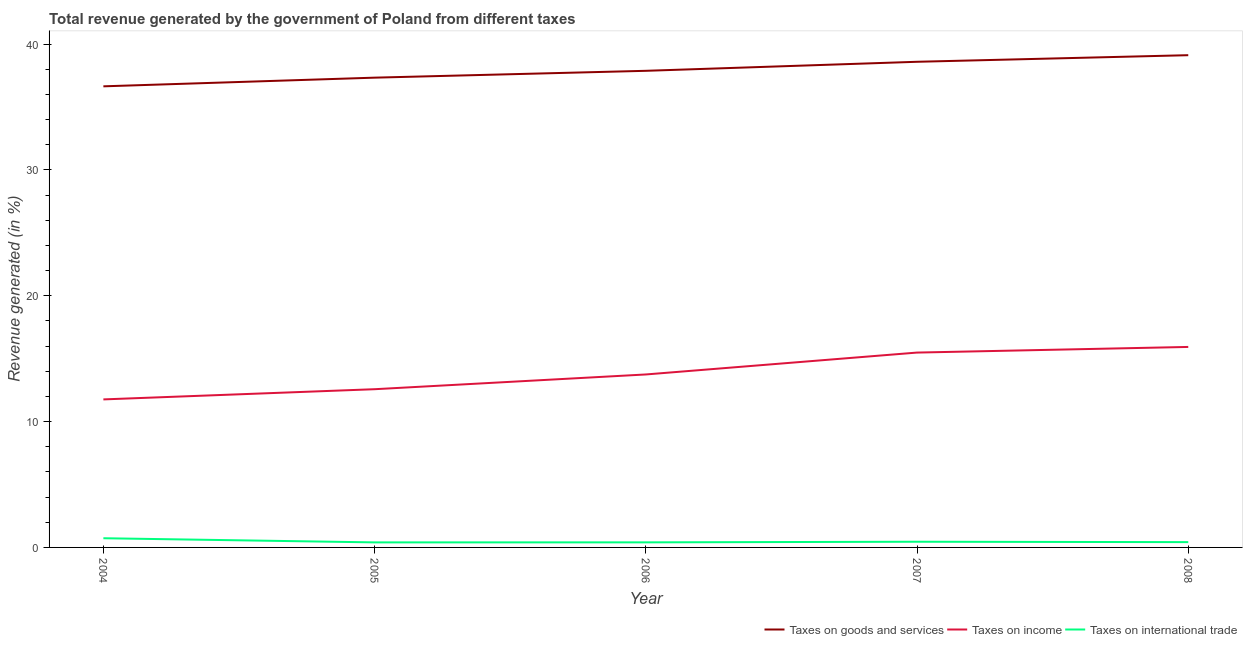How many different coloured lines are there?
Your answer should be compact. 3. Does the line corresponding to percentage of revenue generated by taxes on goods and services intersect with the line corresponding to percentage of revenue generated by taxes on income?
Offer a very short reply. No. What is the percentage of revenue generated by taxes on income in 2008?
Offer a very short reply. 15.93. Across all years, what is the maximum percentage of revenue generated by tax on international trade?
Keep it short and to the point. 0.73. Across all years, what is the minimum percentage of revenue generated by taxes on income?
Ensure brevity in your answer.  11.76. What is the total percentage of revenue generated by taxes on income in the graph?
Give a very brief answer. 69.51. What is the difference between the percentage of revenue generated by taxes on goods and services in 2007 and that in 2008?
Make the answer very short. -0.52. What is the difference between the percentage of revenue generated by taxes on goods and services in 2008 and the percentage of revenue generated by tax on international trade in 2006?
Your answer should be very brief. 38.72. What is the average percentage of revenue generated by tax on international trade per year?
Your response must be concise. 0.48. In the year 2007, what is the difference between the percentage of revenue generated by taxes on income and percentage of revenue generated by taxes on goods and services?
Your answer should be compact. -23.11. What is the ratio of the percentage of revenue generated by taxes on income in 2004 to that in 2006?
Give a very brief answer. 0.86. Is the percentage of revenue generated by taxes on goods and services in 2006 less than that in 2007?
Provide a short and direct response. Yes. What is the difference between the highest and the second highest percentage of revenue generated by tax on international trade?
Give a very brief answer. 0.28. What is the difference between the highest and the lowest percentage of revenue generated by taxes on goods and services?
Your response must be concise. 2.48. Is the sum of the percentage of revenue generated by taxes on income in 2004 and 2008 greater than the maximum percentage of revenue generated by taxes on goods and services across all years?
Your answer should be compact. No. Is the percentage of revenue generated by tax on international trade strictly greater than the percentage of revenue generated by taxes on income over the years?
Provide a succinct answer. No. How many lines are there?
Your response must be concise. 3. What is the difference between two consecutive major ticks on the Y-axis?
Your answer should be very brief. 10. Are the values on the major ticks of Y-axis written in scientific E-notation?
Make the answer very short. No. How many legend labels are there?
Your answer should be very brief. 3. What is the title of the graph?
Make the answer very short. Total revenue generated by the government of Poland from different taxes. Does "Poland" appear as one of the legend labels in the graph?
Provide a succinct answer. No. What is the label or title of the X-axis?
Your answer should be very brief. Year. What is the label or title of the Y-axis?
Your answer should be very brief. Revenue generated (in %). What is the Revenue generated (in %) of Taxes on goods and services in 2004?
Provide a succinct answer. 36.65. What is the Revenue generated (in %) of Taxes on income in 2004?
Your answer should be very brief. 11.76. What is the Revenue generated (in %) of Taxes on international trade in 2004?
Your answer should be compact. 0.73. What is the Revenue generated (in %) of Taxes on goods and services in 2005?
Offer a very short reply. 37.34. What is the Revenue generated (in %) in Taxes on income in 2005?
Provide a short and direct response. 12.57. What is the Revenue generated (in %) of Taxes on international trade in 2005?
Provide a short and direct response. 0.4. What is the Revenue generated (in %) of Taxes on goods and services in 2006?
Your response must be concise. 37.88. What is the Revenue generated (in %) of Taxes on income in 2006?
Offer a terse response. 13.75. What is the Revenue generated (in %) in Taxes on international trade in 2006?
Provide a succinct answer. 0.4. What is the Revenue generated (in %) of Taxes on goods and services in 2007?
Keep it short and to the point. 38.6. What is the Revenue generated (in %) in Taxes on income in 2007?
Your response must be concise. 15.49. What is the Revenue generated (in %) in Taxes on international trade in 2007?
Your answer should be very brief. 0.45. What is the Revenue generated (in %) of Taxes on goods and services in 2008?
Your answer should be very brief. 39.12. What is the Revenue generated (in %) of Taxes on income in 2008?
Your answer should be compact. 15.93. What is the Revenue generated (in %) of Taxes on international trade in 2008?
Make the answer very short. 0.42. Across all years, what is the maximum Revenue generated (in %) in Taxes on goods and services?
Provide a succinct answer. 39.12. Across all years, what is the maximum Revenue generated (in %) of Taxes on income?
Provide a succinct answer. 15.93. Across all years, what is the maximum Revenue generated (in %) in Taxes on international trade?
Give a very brief answer. 0.73. Across all years, what is the minimum Revenue generated (in %) of Taxes on goods and services?
Your answer should be compact. 36.65. Across all years, what is the minimum Revenue generated (in %) of Taxes on income?
Make the answer very short. 11.76. Across all years, what is the minimum Revenue generated (in %) in Taxes on international trade?
Ensure brevity in your answer.  0.4. What is the total Revenue generated (in %) in Taxes on goods and services in the graph?
Your response must be concise. 189.58. What is the total Revenue generated (in %) in Taxes on income in the graph?
Ensure brevity in your answer.  69.51. What is the total Revenue generated (in %) of Taxes on international trade in the graph?
Provide a succinct answer. 2.41. What is the difference between the Revenue generated (in %) in Taxes on goods and services in 2004 and that in 2005?
Your response must be concise. -0.69. What is the difference between the Revenue generated (in %) of Taxes on income in 2004 and that in 2005?
Provide a short and direct response. -0.81. What is the difference between the Revenue generated (in %) of Taxes on international trade in 2004 and that in 2005?
Ensure brevity in your answer.  0.33. What is the difference between the Revenue generated (in %) in Taxes on goods and services in 2004 and that in 2006?
Offer a very short reply. -1.23. What is the difference between the Revenue generated (in %) of Taxes on income in 2004 and that in 2006?
Your answer should be compact. -1.98. What is the difference between the Revenue generated (in %) in Taxes on international trade in 2004 and that in 2006?
Provide a succinct answer. 0.33. What is the difference between the Revenue generated (in %) in Taxes on goods and services in 2004 and that in 2007?
Offer a terse response. -1.95. What is the difference between the Revenue generated (in %) of Taxes on income in 2004 and that in 2007?
Provide a succinct answer. -3.72. What is the difference between the Revenue generated (in %) in Taxes on international trade in 2004 and that in 2007?
Provide a succinct answer. 0.28. What is the difference between the Revenue generated (in %) in Taxes on goods and services in 2004 and that in 2008?
Offer a terse response. -2.48. What is the difference between the Revenue generated (in %) of Taxes on income in 2004 and that in 2008?
Ensure brevity in your answer.  -4.17. What is the difference between the Revenue generated (in %) of Taxes on international trade in 2004 and that in 2008?
Your answer should be compact. 0.31. What is the difference between the Revenue generated (in %) in Taxes on goods and services in 2005 and that in 2006?
Give a very brief answer. -0.54. What is the difference between the Revenue generated (in %) of Taxes on income in 2005 and that in 2006?
Make the answer very short. -1.17. What is the difference between the Revenue generated (in %) in Taxes on international trade in 2005 and that in 2006?
Your answer should be very brief. -0. What is the difference between the Revenue generated (in %) of Taxes on goods and services in 2005 and that in 2007?
Your answer should be very brief. -1.26. What is the difference between the Revenue generated (in %) of Taxes on income in 2005 and that in 2007?
Provide a short and direct response. -2.91. What is the difference between the Revenue generated (in %) in Taxes on international trade in 2005 and that in 2007?
Provide a succinct answer. -0.05. What is the difference between the Revenue generated (in %) of Taxes on goods and services in 2005 and that in 2008?
Your response must be concise. -1.79. What is the difference between the Revenue generated (in %) in Taxes on income in 2005 and that in 2008?
Offer a terse response. -3.36. What is the difference between the Revenue generated (in %) in Taxes on international trade in 2005 and that in 2008?
Your answer should be very brief. -0.02. What is the difference between the Revenue generated (in %) in Taxes on goods and services in 2006 and that in 2007?
Ensure brevity in your answer.  -0.72. What is the difference between the Revenue generated (in %) of Taxes on income in 2006 and that in 2007?
Your response must be concise. -1.74. What is the difference between the Revenue generated (in %) in Taxes on international trade in 2006 and that in 2007?
Offer a terse response. -0.05. What is the difference between the Revenue generated (in %) of Taxes on goods and services in 2006 and that in 2008?
Your response must be concise. -1.24. What is the difference between the Revenue generated (in %) in Taxes on income in 2006 and that in 2008?
Provide a succinct answer. -2.19. What is the difference between the Revenue generated (in %) of Taxes on international trade in 2006 and that in 2008?
Your answer should be compact. -0.02. What is the difference between the Revenue generated (in %) in Taxes on goods and services in 2007 and that in 2008?
Offer a terse response. -0.52. What is the difference between the Revenue generated (in %) of Taxes on income in 2007 and that in 2008?
Offer a very short reply. -0.45. What is the difference between the Revenue generated (in %) in Taxes on international trade in 2007 and that in 2008?
Provide a short and direct response. 0.03. What is the difference between the Revenue generated (in %) in Taxes on goods and services in 2004 and the Revenue generated (in %) in Taxes on income in 2005?
Provide a succinct answer. 24.07. What is the difference between the Revenue generated (in %) in Taxes on goods and services in 2004 and the Revenue generated (in %) in Taxes on international trade in 2005?
Your answer should be compact. 36.25. What is the difference between the Revenue generated (in %) in Taxes on income in 2004 and the Revenue generated (in %) in Taxes on international trade in 2005?
Your response must be concise. 11.36. What is the difference between the Revenue generated (in %) of Taxes on goods and services in 2004 and the Revenue generated (in %) of Taxes on income in 2006?
Your answer should be compact. 22.9. What is the difference between the Revenue generated (in %) of Taxes on goods and services in 2004 and the Revenue generated (in %) of Taxes on international trade in 2006?
Provide a succinct answer. 36.24. What is the difference between the Revenue generated (in %) of Taxes on income in 2004 and the Revenue generated (in %) of Taxes on international trade in 2006?
Your answer should be compact. 11.36. What is the difference between the Revenue generated (in %) of Taxes on goods and services in 2004 and the Revenue generated (in %) of Taxes on income in 2007?
Offer a terse response. 21.16. What is the difference between the Revenue generated (in %) of Taxes on goods and services in 2004 and the Revenue generated (in %) of Taxes on international trade in 2007?
Provide a succinct answer. 36.19. What is the difference between the Revenue generated (in %) in Taxes on income in 2004 and the Revenue generated (in %) in Taxes on international trade in 2007?
Make the answer very short. 11.31. What is the difference between the Revenue generated (in %) in Taxes on goods and services in 2004 and the Revenue generated (in %) in Taxes on income in 2008?
Your response must be concise. 20.71. What is the difference between the Revenue generated (in %) of Taxes on goods and services in 2004 and the Revenue generated (in %) of Taxes on international trade in 2008?
Keep it short and to the point. 36.22. What is the difference between the Revenue generated (in %) in Taxes on income in 2004 and the Revenue generated (in %) in Taxes on international trade in 2008?
Your answer should be very brief. 11.34. What is the difference between the Revenue generated (in %) in Taxes on goods and services in 2005 and the Revenue generated (in %) in Taxes on income in 2006?
Provide a short and direct response. 23.59. What is the difference between the Revenue generated (in %) of Taxes on goods and services in 2005 and the Revenue generated (in %) of Taxes on international trade in 2006?
Provide a short and direct response. 36.93. What is the difference between the Revenue generated (in %) of Taxes on income in 2005 and the Revenue generated (in %) of Taxes on international trade in 2006?
Keep it short and to the point. 12.17. What is the difference between the Revenue generated (in %) in Taxes on goods and services in 2005 and the Revenue generated (in %) in Taxes on income in 2007?
Ensure brevity in your answer.  21.85. What is the difference between the Revenue generated (in %) in Taxes on goods and services in 2005 and the Revenue generated (in %) in Taxes on international trade in 2007?
Make the answer very short. 36.88. What is the difference between the Revenue generated (in %) in Taxes on income in 2005 and the Revenue generated (in %) in Taxes on international trade in 2007?
Make the answer very short. 12.12. What is the difference between the Revenue generated (in %) in Taxes on goods and services in 2005 and the Revenue generated (in %) in Taxes on income in 2008?
Keep it short and to the point. 21.4. What is the difference between the Revenue generated (in %) of Taxes on goods and services in 2005 and the Revenue generated (in %) of Taxes on international trade in 2008?
Your answer should be compact. 36.91. What is the difference between the Revenue generated (in %) of Taxes on income in 2005 and the Revenue generated (in %) of Taxes on international trade in 2008?
Make the answer very short. 12.15. What is the difference between the Revenue generated (in %) of Taxes on goods and services in 2006 and the Revenue generated (in %) of Taxes on income in 2007?
Provide a short and direct response. 22.39. What is the difference between the Revenue generated (in %) of Taxes on goods and services in 2006 and the Revenue generated (in %) of Taxes on international trade in 2007?
Offer a terse response. 37.43. What is the difference between the Revenue generated (in %) of Taxes on income in 2006 and the Revenue generated (in %) of Taxes on international trade in 2007?
Give a very brief answer. 13.29. What is the difference between the Revenue generated (in %) in Taxes on goods and services in 2006 and the Revenue generated (in %) in Taxes on income in 2008?
Offer a terse response. 21.95. What is the difference between the Revenue generated (in %) in Taxes on goods and services in 2006 and the Revenue generated (in %) in Taxes on international trade in 2008?
Your answer should be compact. 37.46. What is the difference between the Revenue generated (in %) in Taxes on income in 2006 and the Revenue generated (in %) in Taxes on international trade in 2008?
Offer a very short reply. 13.33. What is the difference between the Revenue generated (in %) of Taxes on goods and services in 2007 and the Revenue generated (in %) of Taxes on income in 2008?
Your response must be concise. 22.66. What is the difference between the Revenue generated (in %) in Taxes on goods and services in 2007 and the Revenue generated (in %) in Taxes on international trade in 2008?
Offer a terse response. 38.18. What is the difference between the Revenue generated (in %) of Taxes on income in 2007 and the Revenue generated (in %) of Taxes on international trade in 2008?
Provide a short and direct response. 15.07. What is the average Revenue generated (in %) in Taxes on goods and services per year?
Keep it short and to the point. 37.92. What is the average Revenue generated (in %) in Taxes on income per year?
Your response must be concise. 13.9. What is the average Revenue generated (in %) of Taxes on international trade per year?
Keep it short and to the point. 0.48. In the year 2004, what is the difference between the Revenue generated (in %) of Taxes on goods and services and Revenue generated (in %) of Taxes on income?
Offer a terse response. 24.88. In the year 2004, what is the difference between the Revenue generated (in %) of Taxes on goods and services and Revenue generated (in %) of Taxes on international trade?
Provide a short and direct response. 35.92. In the year 2004, what is the difference between the Revenue generated (in %) in Taxes on income and Revenue generated (in %) in Taxes on international trade?
Offer a terse response. 11.03. In the year 2005, what is the difference between the Revenue generated (in %) in Taxes on goods and services and Revenue generated (in %) in Taxes on income?
Your answer should be compact. 24.76. In the year 2005, what is the difference between the Revenue generated (in %) in Taxes on goods and services and Revenue generated (in %) in Taxes on international trade?
Provide a succinct answer. 36.93. In the year 2005, what is the difference between the Revenue generated (in %) in Taxes on income and Revenue generated (in %) in Taxes on international trade?
Your answer should be very brief. 12.17. In the year 2006, what is the difference between the Revenue generated (in %) of Taxes on goods and services and Revenue generated (in %) of Taxes on income?
Your answer should be very brief. 24.13. In the year 2006, what is the difference between the Revenue generated (in %) of Taxes on goods and services and Revenue generated (in %) of Taxes on international trade?
Offer a very short reply. 37.48. In the year 2006, what is the difference between the Revenue generated (in %) of Taxes on income and Revenue generated (in %) of Taxes on international trade?
Offer a very short reply. 13.34. In the year 2007, what is the difference between the Revenue generated (in %) of Taxes on goods and services and Revenue generated (in %) of Taxes on income?
Make the answer very short. 23.11. In the year 2007, what is the difference between the Revenue generated (in %) in Taxes on goods and services and Revenue generated (in %) in Taxes on international trade?
Your answer should be compact. 38.14. In the year 2007, what is the difference between the Revenue generated (in %) in Taxes on income and Revenue generated (in %) in Taxes on international trade?
Provide a short and direct response. 15.03. In the year 2008, what is the difference between the Revenue generated (in %) of Taxes on goods and services and Revenue generated (in %) of Taxes on income?
Provide a succinct answer. 23.19. In the year 2008, what is the difference between the Revenue generated (in %) of Taxes on goods and services and Revenue generated (in %) of Taxes on international trade?
Offer a terse response. 38.7. In the year 2008, what is the difference between the Revenue generated (in %) of Taxes on income and Revenue generated (in %) of Taxes on international trade?
Provide a short and direct response. 15.51. What is the ratio of the Revenue generated (in %) of Taxes on goods and services in 2004 to that in 2005?
Ensure brevity in your answer.  0.98. What is the ratio of the Revenue generated (in %) in Taxes on income in 2004 to that in 2005?
Give a very brief answer. 0.94. What is the ratio of the Revenue generated (in %) of Taxes on international trade in 2004 to that in 2005?
Your answer should be compact. 1.82. What is the ratio of the Revenue generated (in %) in Taxes on goods and services in 2004 to that in 2006?
Keep it short and to the point. 0.97. What is the ratio of the Revenue generated (in %) of Taxes on income in 2004 to that in 2006?
Keep it short and to the point. 0.86. What is the ratio of the Revenue generated (in %) in Taxes on international trade in 2004 to that in 2006?
Provide a short and direct response. 1.81. What is the ratio of the Revenue generated (in %) in Taxes on goods and services in 2004 to that in 2007?
Offer a terse response. 0.95. What is the ratio of the Revenue generated (in %) of Taxes on income in 2004 to that in 2007?
Your answer should be very brief. 0.76. What is the ratio of the Revenue generated (in %) in Taxes on international trade in 2004 to that in 2007?
Offer a terse response. 1.62. What is the ratio of the Revenue generated (in %) in Taxes on goods and services in 2004 to that in 2008?
Your answer should be compact. 0.94. What is the ratio of the Revenue generated (in %) of Taxes on income in 2004 to that in 2008?
Offer a very short reply. 0.74. What is the ratio of the Revenue generated (in %) of Taxes on international trade in 2004 to that in 2008?
Provide a short and direct response. 1.74. What is the ratio of the Revenue generated (in %) in Taxes on goods and services in 2005 to that in 2006?
Provide a succinct answer. 0.99. What is the ratio of the Revenue generated (in %) in Taxes on income in 2005 to that in 2006?
Provide a short and direct response. 0.91. What is the ratio of the Revenue generated (in %) in Taxes on goods and services in 2005 to that in 2007?
Give a very brief answer. 0.97. What is the ratio of the Revenue generated (in %) of Taxes on income in 2005 to that in 2007?
Make the answer very short. 0.81. What is the ratio of the Revenue generated (in %) of Taxes on international trade in 2005 to that in 2007?
Provide a short and direct response. 0.89. What is the ratio of the Revenue generated (in %) of Taxes on goods and services in 2005 to that in 2008?
Your answer should be compact. 0.95. What is the ratio of the Revenue generated (in %) of Taxes on income in 2005 to that in 2008?
Your answer should be compact. 0.79. What is the ratio of the Revenue generated (in %) of Taxes on international trade in 2005 to that in 2008?
Provide a short and direct response. 0.95. What is the ratio of the Revenue generated (in %) of Taxes on goods and services in 2006 to that in 2007?
Your answer should be compact. 0.98. What is the ratio of the Revenue generated (in %) of Taxes on income in 2006 to that in 2007?
Ensure brevity in your answer.  0.89. What is the ratio of the Revenue generated (in %) of Taxes on international trade in 2006 to that in 2007?
Your response must be concise. 0.89. What is the ratio of the Revenue generated (in %) in Taxes on goods and services in 2006 to that in 2008?
Your answer should be very brief. 0.97. What is the ratio of the Revenue generated (in %) of Taxes on income in 2006 to that in 2008?
Provide a succinct answer. 0.86. What is the ratio of the Revenue generated (in %) in Taxes on international trade in 2006 to that in 2008?
Your answer should be very brief. 0.96. What is the ratio of the Revenue generated (in %) in Taxes on goods and services in 2007 to that in 2008?
Your response must be concise. 0.99. What is the ratio of the Revenue generated (in %) of Taxes on income in 2007 to that in 2008?
Keep it short and to the point. 0.97. What is the ratio of the Revenue generated (in %) of Taxes on international trade in 2007 to that in 2008?
Your answer should be compact. 1.07. What is the difference between the highest and the second highest Revenue generated (in %) of Taxes on goods and services?
Offer a terse response. 0.52. What is the difference between the highest and the second highest Revenue generated (in %) in Taxes on income?
Offer a terse response. 0.45. What is the difference between the highest and the second highest Revenue generated (in %) in Taxes on international trade?
Your answer should be very brief. 0.28. What is the difference between the highest and the lowest Revenue generated (in %) of Taxes on goods and services?
Give a very brief answer. 2.48. What is the difference between the highest and the lowest Revenue generated (in %) in Taxes on income?
Keep it short and to the point. 4.17. What is the difference between the highest and the lowest Revenue generated (in %) in Taxes on international trade?
Your answer should be very brief. 0.33. 